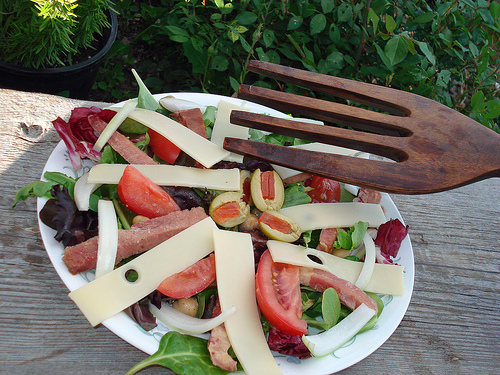<image>
Is there a fork on the food plate? No. The fork is not positioned on the food plate. They may be near each other, but the fork is not supported by or resting on top of the food plate. 